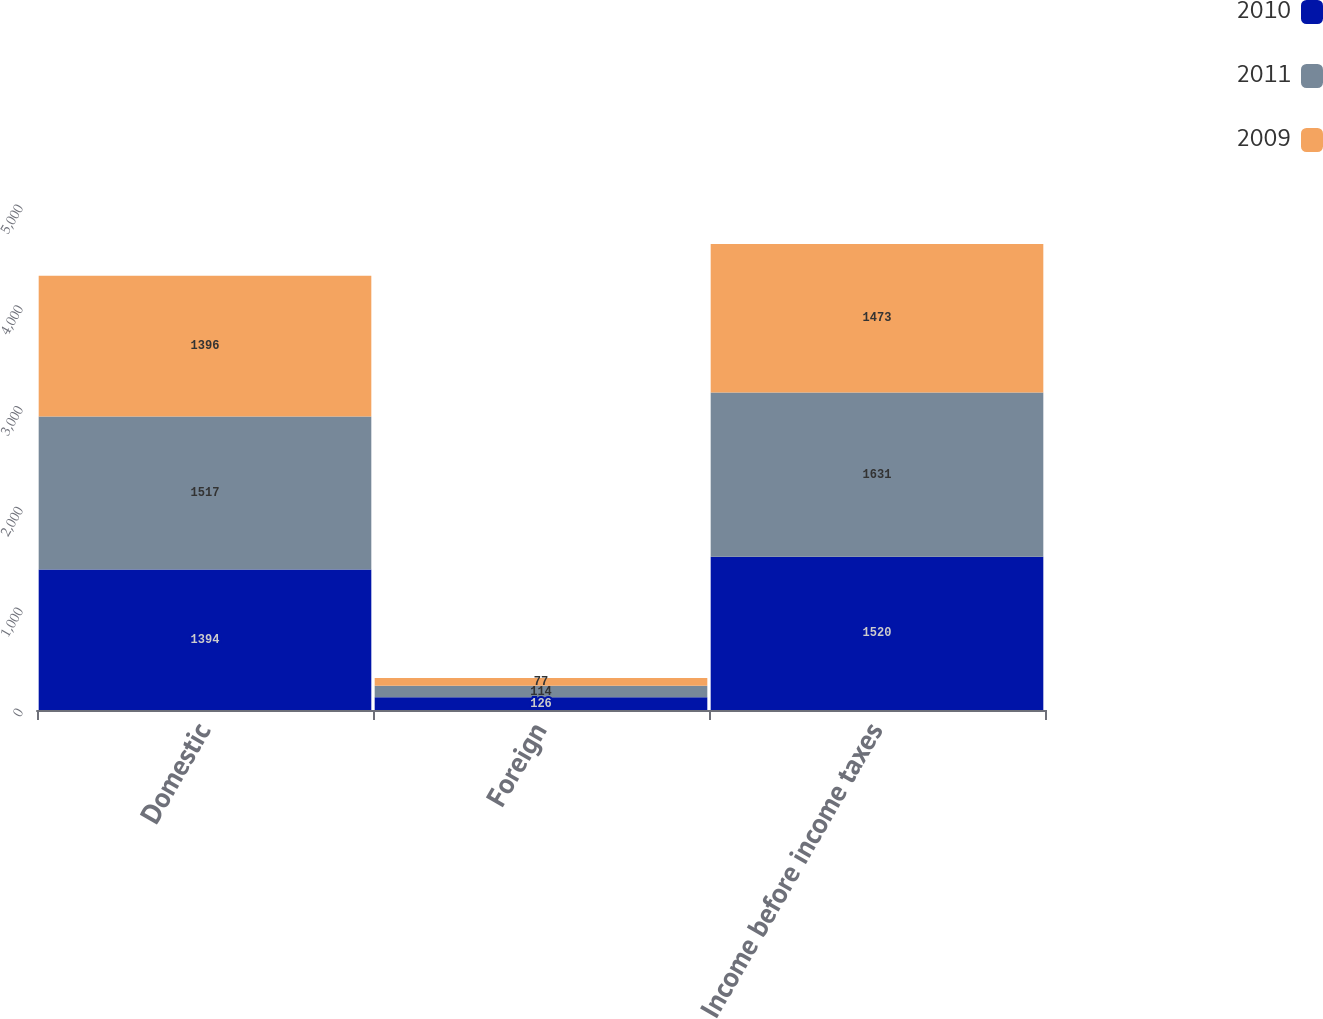Convert chart. <chart><loc_0><loc_0><loc_500><loc_500><stacked_bar_chart><ecel><fcel>Domestic<fcel>Foreign<fcel>Income before income taxes<nl><fcel>2010<fcel>1394<fcel>126<fcel>1520<nl><fcel>2011<fcel>1517<fcel>114<fcel>1631<nl><fcel>2009<fcel>1396<fcel>77<fcel>1473<nl></chart> 